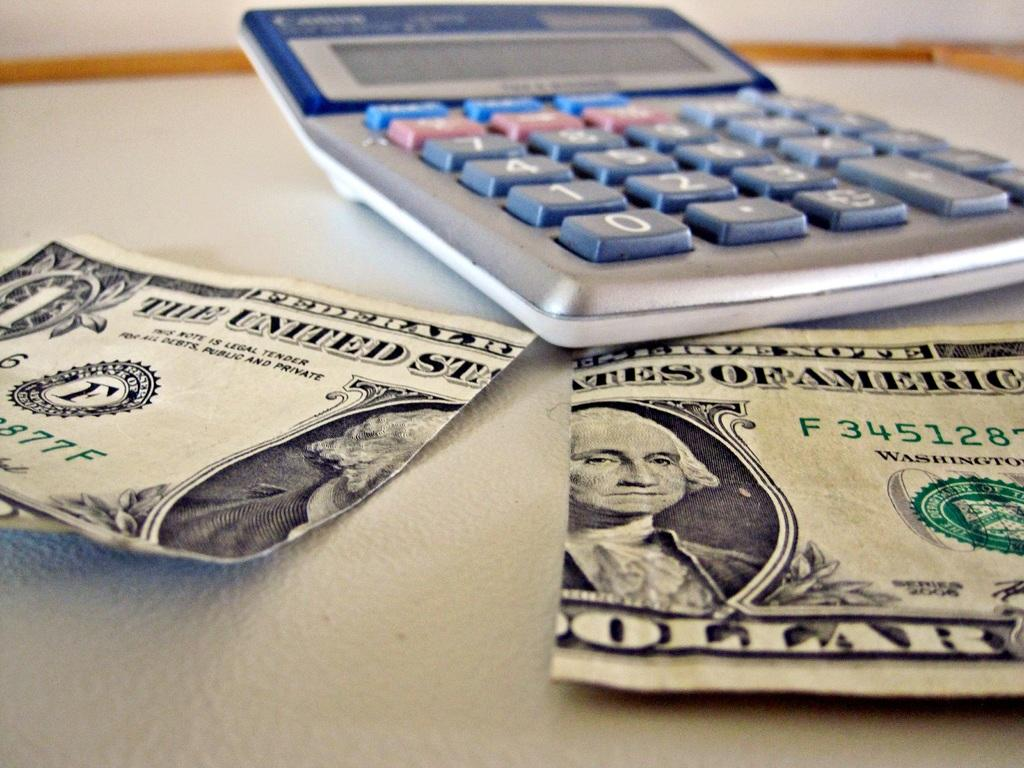Provide a one-sentence caption for the provided image. A calculator and ripped Dollar Bill on a table. 